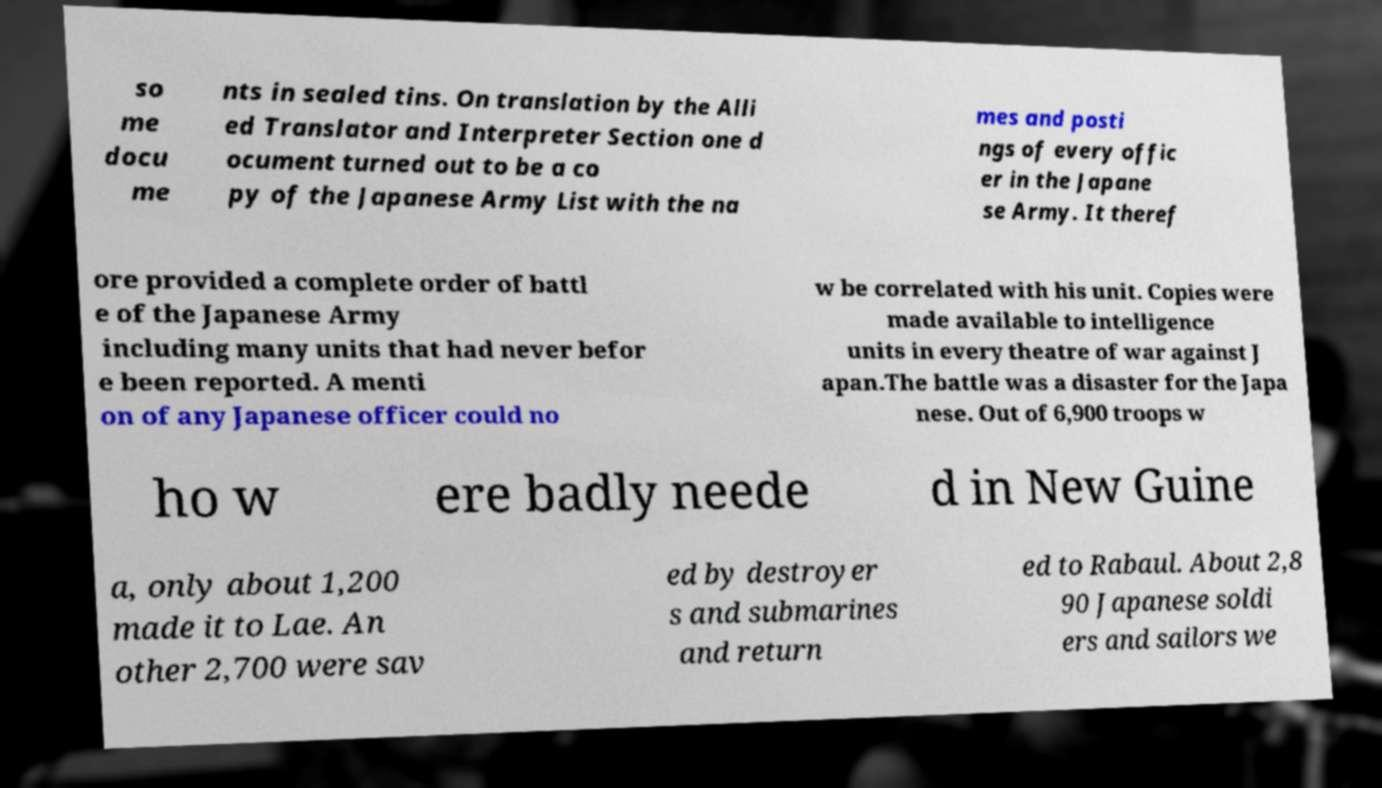Can you accurately transcribe the text from the provided image for me? so me docu me nts in sealed tins. On translation by the Alli ed Translator and Interpreter Section one d ocument turned out to be a co py of the Japanese Army List with the na mes and posti ngs of every offic er in the Japane se Army. It theref ore provided a complete order of battl e of the Japanese Army including many units that had never befor e been reported. A menti on of any Japanese officer could no w be correlated with his unit. Copies were made available to intelligence units in every theatre of war against J apan.The battle was a disaster for the Japa nese. Out of 6,900 troops w ho w ere badly neede d in New Guine a, only about 1,200 made it to Lae. An other 2,700 were sav ed by destroyer s and submarines and return ed to Rabaul. About 2,8 90 Japanese soldi ers and sailors we 